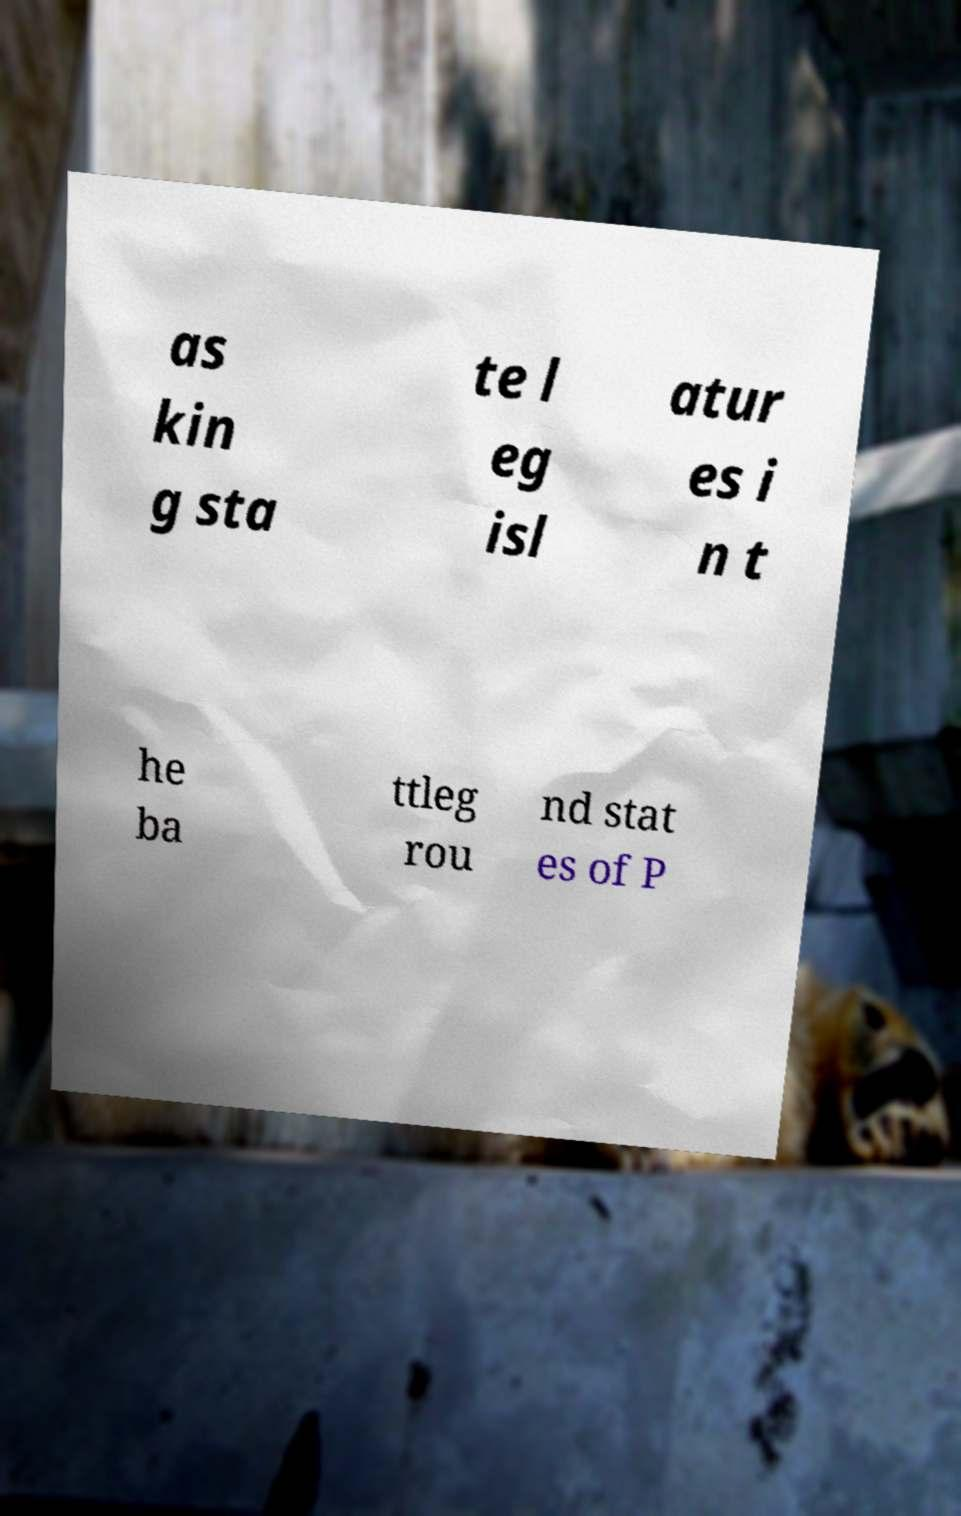For documentation purposes, I need the text within this image transcribed. Could you provide that? as kin g sta te l eg isl atur es i n t he ba ttleg rou nd stat es of P 